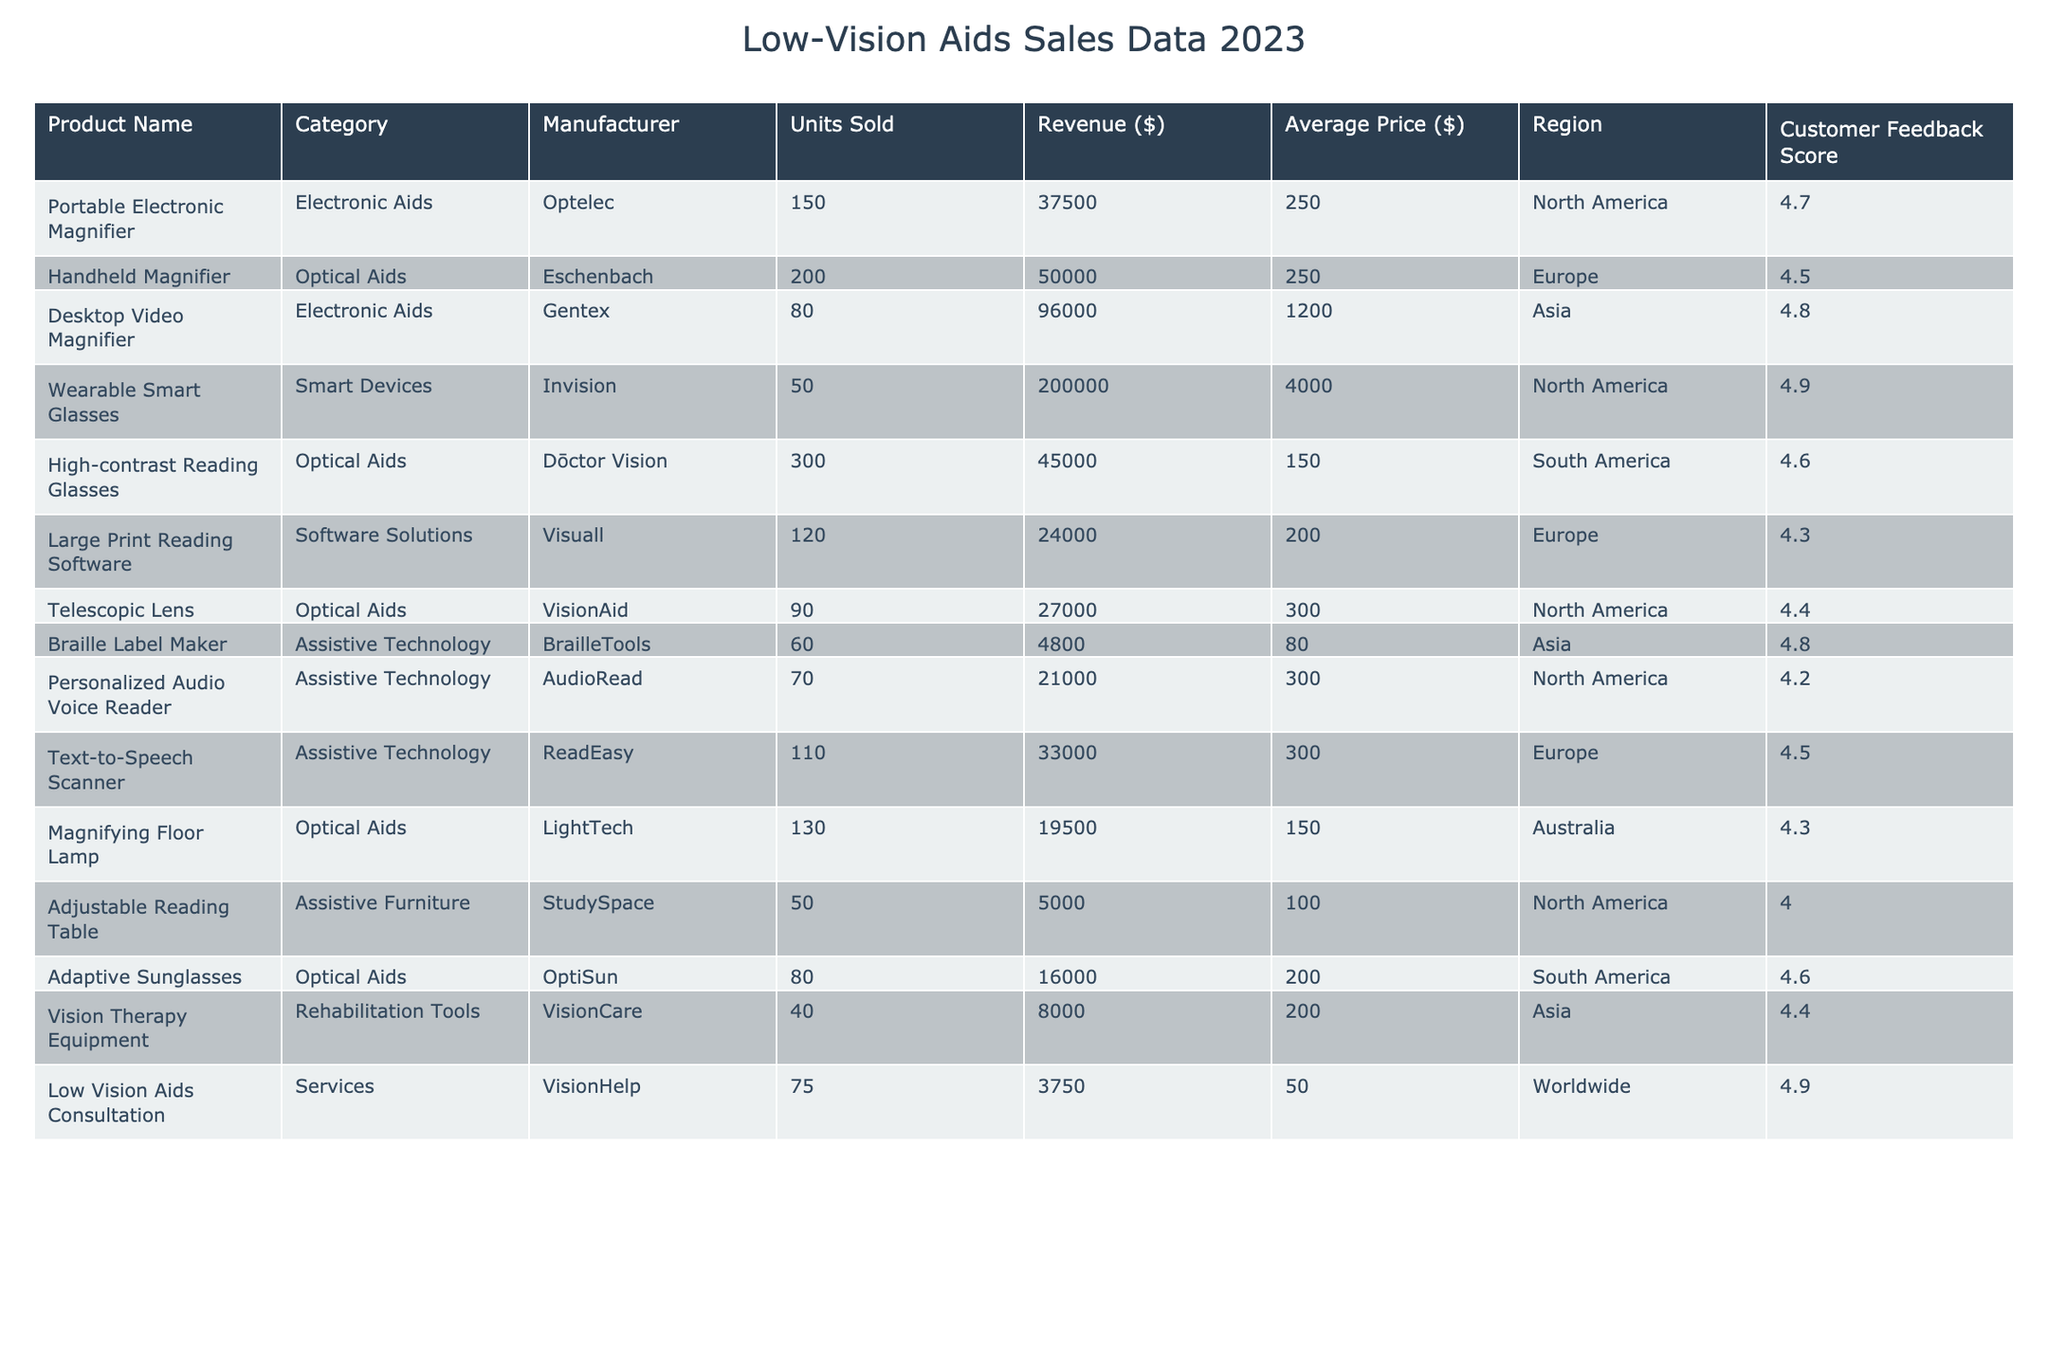What is the total revenue generated from the sales of Wearable Smart Glasses? According to the table, the revenue for Wearable Smart Glasses is listed as $200,000. Since we are only interested in that specific product's total revenue, we directly take this amount from the table.
Answer: 200000 Which product in the Optical Aids category had the highest Customer Feedback Score? In the Optical Aids category, we look at the Customer Feedback Scores of High-contrast Reading Glasses (4.6), Handheld Magnifier (4.5), and Telescopic Lens (4.4). The highest score among these is for High-contrast Reading Glasses, which is 4.6.
Answer: High-contrast Reading Glasses What is the average price of all the Electronic Aids sold? The products in the Electronic Aids category are Portable Electronic Magnifier (250), and Desktop Video Magnifier (1200). To find the average price, we sum the prices (250 + 1200 = 1450) and divide by the number of products (2): 1450/2 = 725.
Answer: 725 Did the sales of Adjustable Reading Table generate more than $5,000 in revenue? The revenue for Adjustable Reading Table is listed as $5,000. Since the question asks if it generated more than this amount, we notice it is exactly $5,000, making the answer false.
Answer: False Which region had the most units sold in the Assistive Technology category? In the Assistive Technology category, we consider Braille Label Maker (60, Asia), Personalized Audio Voice Reader (70, North America), Text-to-Speech Scanner (110, Europe). Summing these gives North America 70, Asia 60, and Europe 110. Europe has the highest units sold with 110.
Answer: Europe What is the total number of units sold across all categories in South America? From South America, we have two products: High-contrast Reading Glasses with 300 units sold and Adaptive Sunglasses with 80 units sold. Summing these quantities gives us 300 + 80 = 380 units sold in total.
Answer: 380 Are there any products in the table with a Customer Feedback Score below 4.0? The table lists the Customer Feedback Scores, and checking all the values reveals that the lowest score is 4.0 for the Adjustable Reading Table. Therefore, there are no products with scores below 4.0.
Answer: No Which product sold the fewest units in the table, and what was the total revenue for that product? Reviewing the Units Sold column, we find that Vision Therapy Equipment is the product with the fewest units sold (40). Its revenue is reported at $8,000. Therefore, we identify the product and its corresponding revenue from the data.
Answer: Vision Therapy Equipment, 8000 